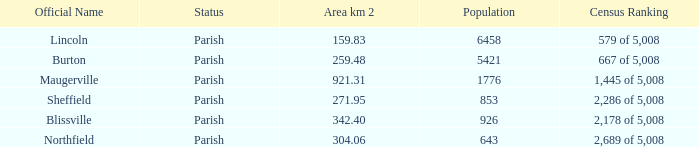What are the formal designations for locations that encompass 304.06 square kilometers? Northfield. 